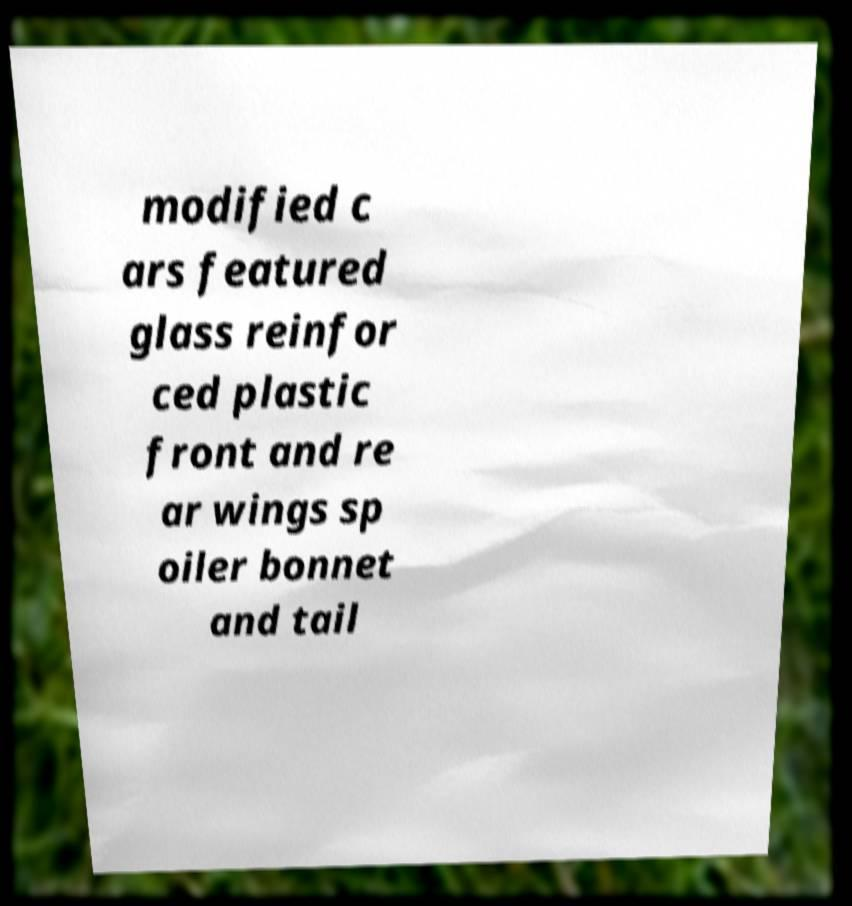For documentation purposes, I need the text within this image transcribed. Could you provide that? modified c ars featured glass reinfor ced plastic front and re ar wings sp oiler bonnet and tail 